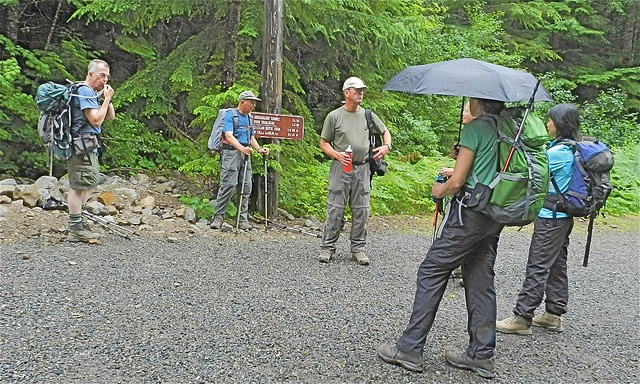Describe the objects in this image and their specific colors. I can see people in olive, gray, black, darkgray, and teal tones, people in olive, gray, black, darkgray, and lightblue tones, people in olive, darkgray, gray, black, and lightgray tones, backpack in olive, gray, green, darkgreen, and black tones, and people in olive, gray, darkgray, black, and lightgray tones in this image. 